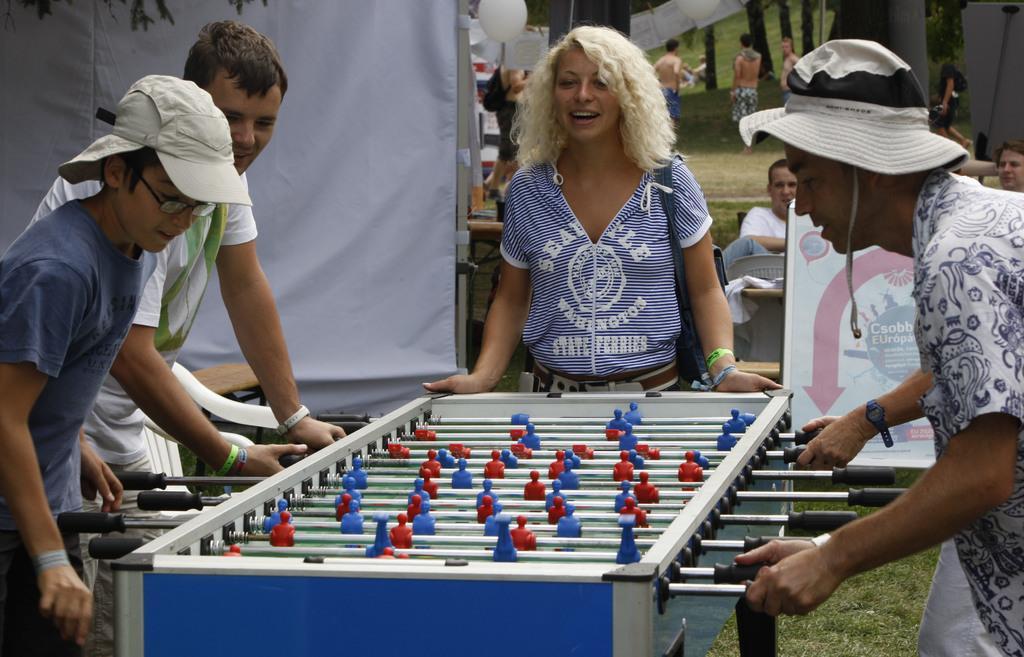How would you summarize this image in a sentence or two? In this picture we can observe four members standing around the table on which we can observe a game. Two of them were wearing hats on their heads and playing this indoor game. We can observe a woman wearing blue color shirt. In the background there are some people sitting and standing. On the left side we can observe white color cloth. 